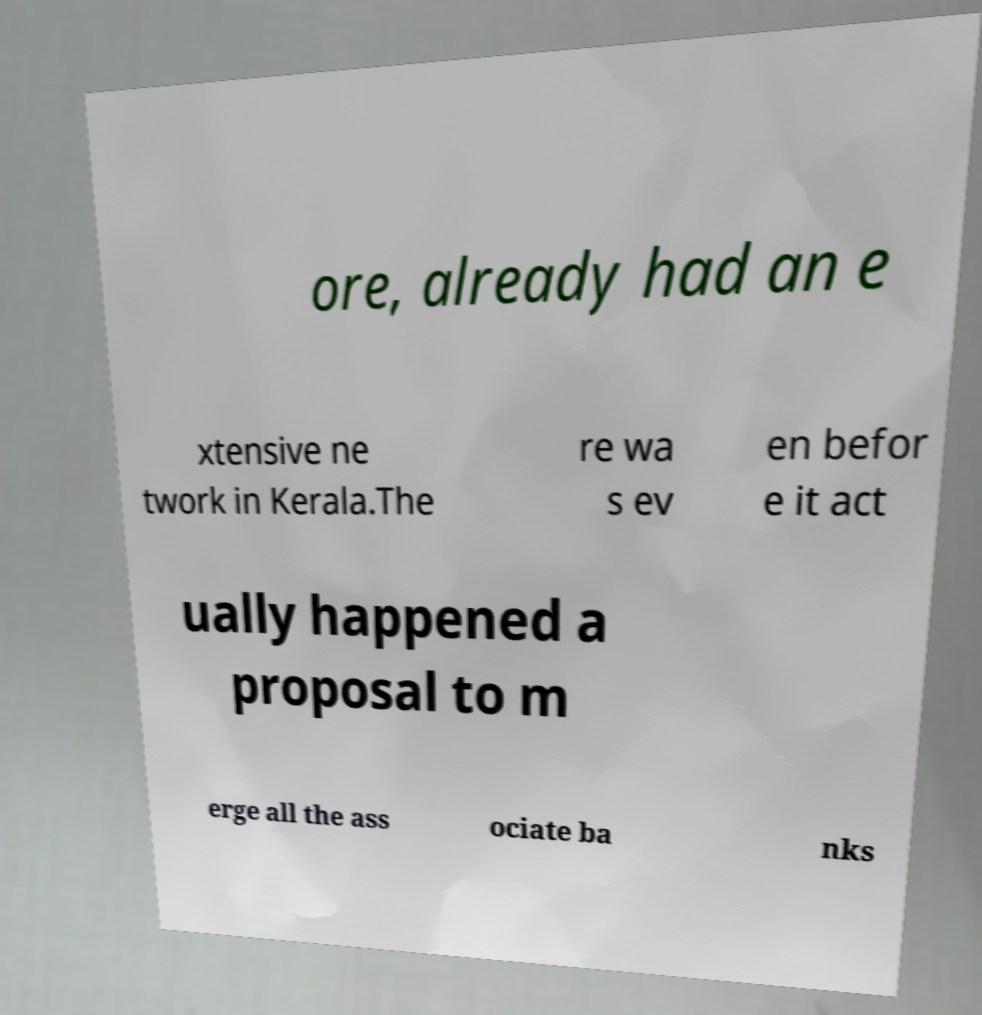What messages or text are displayed in this image? I need them in a readable, typed format. ore, already had an e xtensive ne twork in Kerala.The re wa s ev en befor e it act ually happened a proposal to m erge all the ass ociate ba nks 